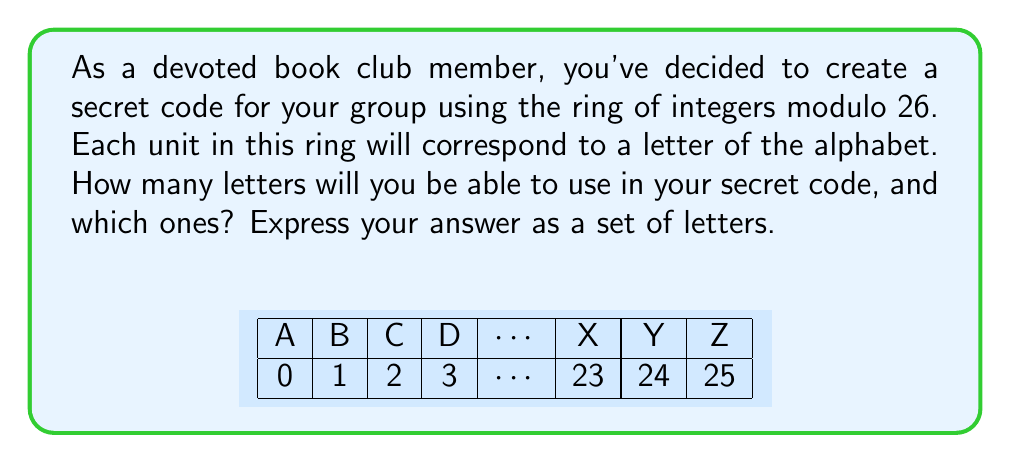Give your solution to this math problem. Let's approach this step-by-step:

1) In the ring of integers modulo 26, denoted as $\mathbb{Z}_{26}$, the elements are $\{0, 1, 2, ..., 25\}$.

2) A unit in a ring is an element that has a multiplicative inverse. In $\mathbb{Z}_{26}$, an element $a$ is a unit if there exists a $b$ such that $ab \equiv 1 \pmod{26}$.

3) To find the units, we need to find all numbers coprime to 26. Two numbers are coprime if their greatest common divisor (GCD) is 1.

4) The factors of 26 are 1, 2, 13, and 26. Any number that shares a factor with 26 (other than 1) will not be coprime to 26.

5) Therefore, the units are the numbers in $\mathbb{Z}_{26}$ that are not divisible by 2 or 13:

   $\{1, 3, 5, 7, 9, 11, 15, 17, 19, 21, 23, 25\}$

6) There are 12 such numbers.

7) Associating these with letters of the alphabet (where A=1, B=2, ..., Z=26), we get:

   $\{A, C, E, G, I, K, O, Q, S, U, W, Y\}$

Therefore, you can use 12 letters in your secret code: A, C, E, G, I, K, O, Q, S, U, W, and Y.
Answer: $\{A, C, E, G, I, K, O, Q, S, U, W, Y\}$ 